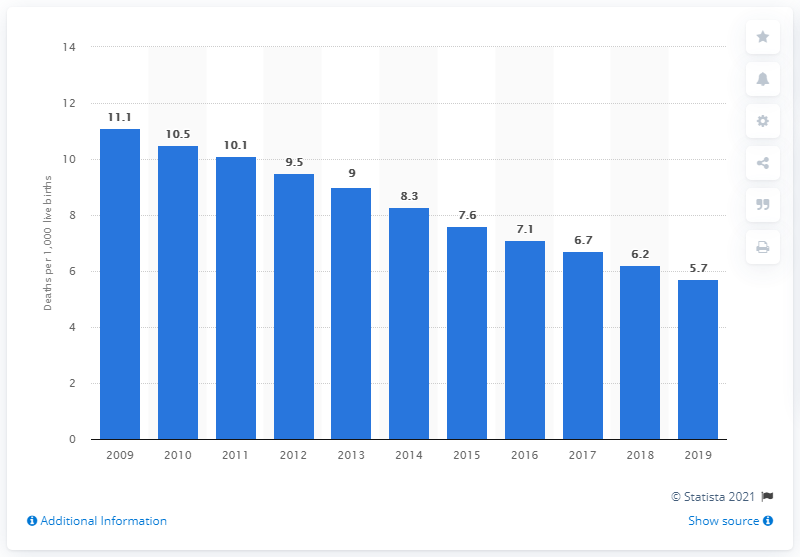Mention a couple of crucial points in this snapshot. In 2019, the infant mortality rate in Romania was 5.7 deaths per 1,000 live births. 